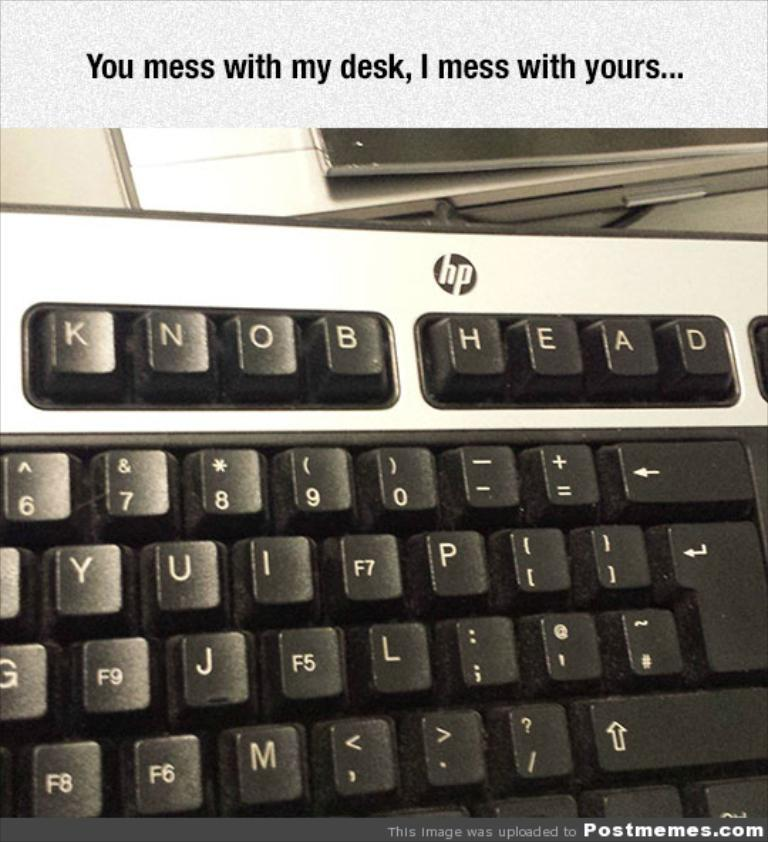<image>
Write a terse but informative summary of the picture. someone changed the keys on the top of a keyboard to say knob head 